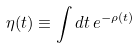Convert formula to latex. <formula><loc_0><loc_0><loc_500><loc_500>\eta ( t ) \equiv \int d t \, e ^ { - \rho ( t ) }</formula> 